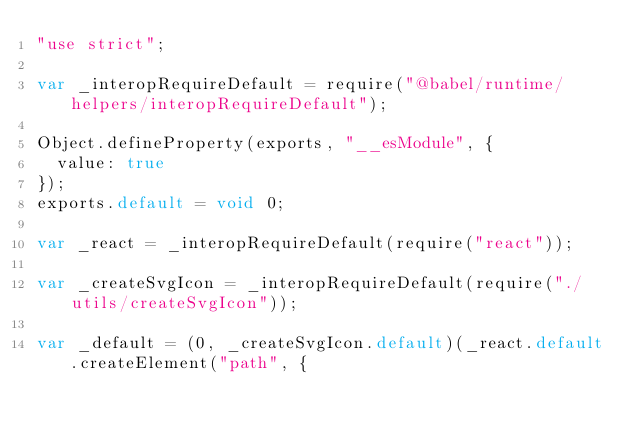<code> <loc_0><loc_0><loc_500><loc_500><_JavaScript_>"use strict";

var _interopRequireDefault = require("@babel/runtime/helpers/interopRequireDefault");

Object.defineProperty(exports, "__esModule", {
  value: true
});
exports.default = void 0;

var _react = _interopRequireDefault(require("react"));

var _createSvgIcon = _interopRequireDefault(require("./utils/createSvgIcon"));

var _default = (0, _createSvgIcon.default)(_react.default.createElement("path", {</code> 